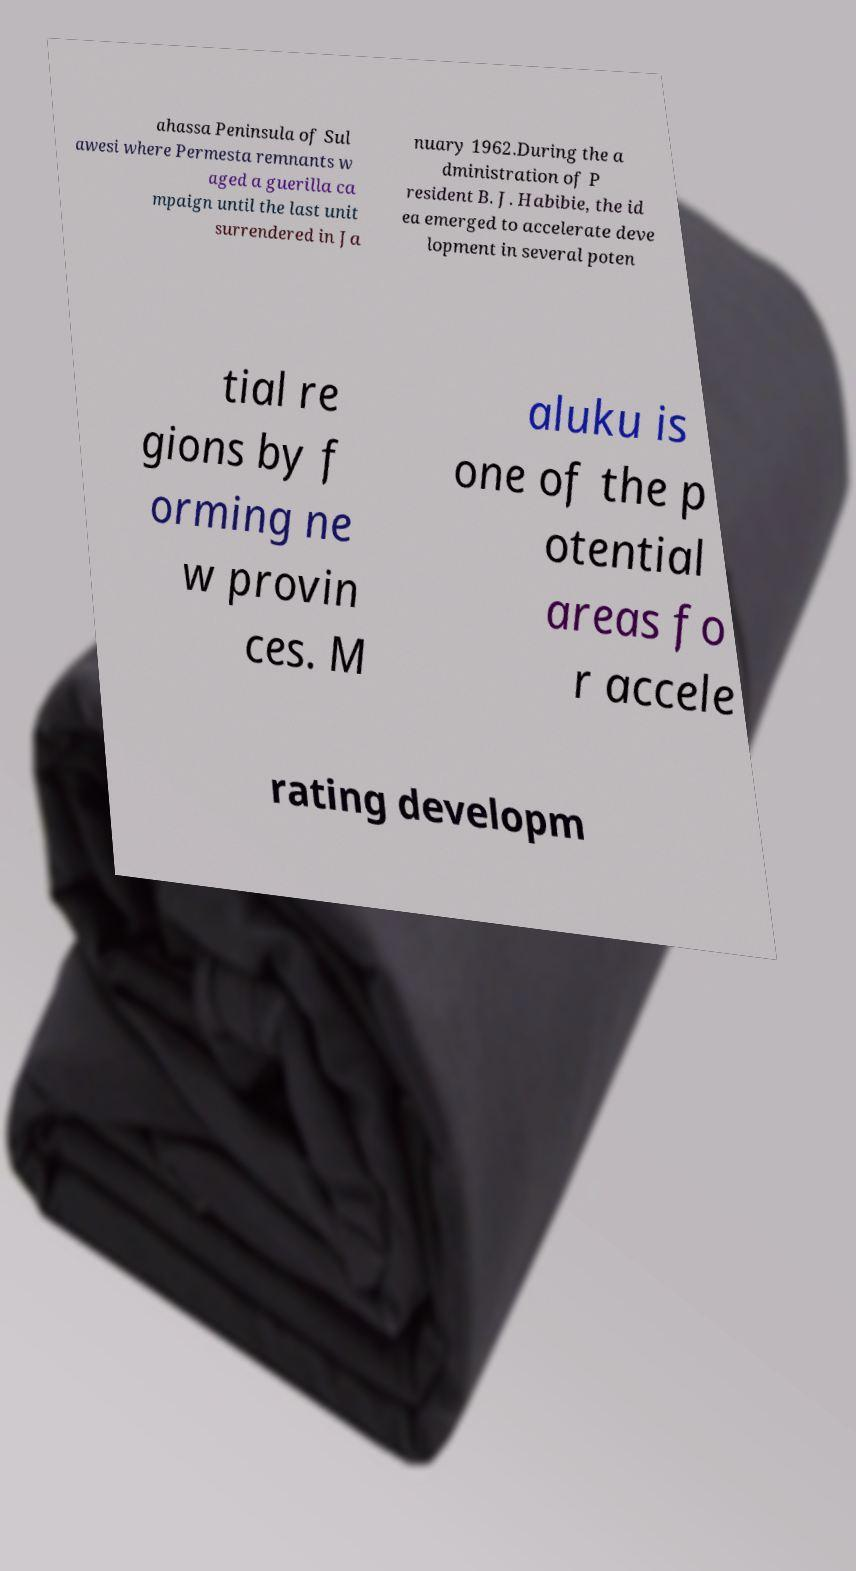There's text embedded in this image that I need extracted. Can you transcribe it verbatim? ahassa Peninsula of Sul awesi where Permesta remnants w aged a guerilla ca mpaign until the last unit surrendered in Ja nuary 1962.During the a dministration of P resident B. J. Habibie, the id ea emerged to accelerate deve lopment in several poten tial re gions by f orming ne w provin ces. M aluku is one of the p otential areas fo r accele rating developm 